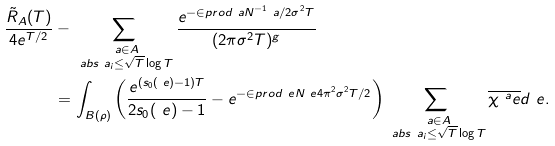<formula> <loc_0><loc_0><loc_500><loc_500>\frac { \tilde { R } _ { A } ( T ) } { 4 e ^ { T / 2 } } & - \sum _ { \substack { \ a \in A \\ \ a b s { \ a _ { i } } \leq \sqrt { T } \log T } } \frac { e ^ { - \in p r o d { \ a } { N ^ { - 1 } \ a } / 2 \sigma ^ { 2 } T } } { ( 2 \pi \sigma ^ { 2 } T ) ^ { g } } \\ & = \int _ { B ( \rho ) } \left ( \frac { e ^ { ( s _ { 0 } ( \ e ) - 1 ) T } } { 2 s _ { 0 } ( \ e ) - 1 } - e ^ { - \in p r o d { \ e } { N \ e } 4 \pi ^ { 2 } \sigma ^ { 2 } T / 2 } \right ) \sum _ { \substack { \ a \in A \\ \ a b s { \ a _ { i } } \leq \sqrt { T } \log T } } \overline { \chi ^ { \ a } _ { \ } e } d \ e .</formula> 